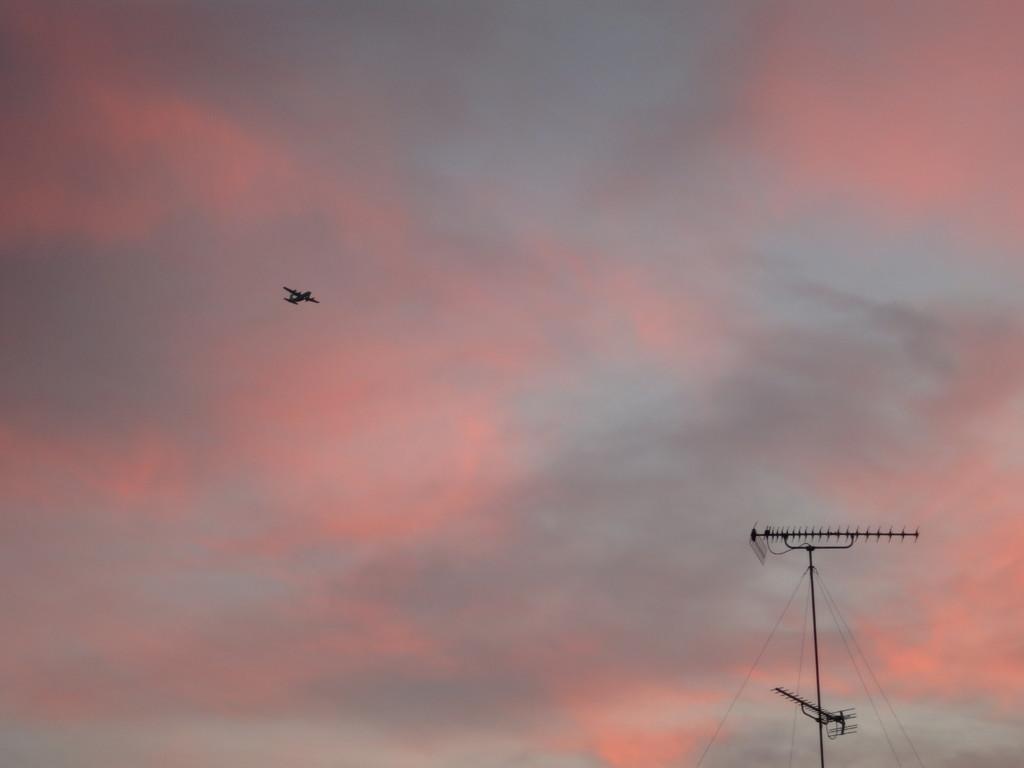Could you give a brief overview of what you see in this image? In this image there is a power station, aeroplane and sky. 